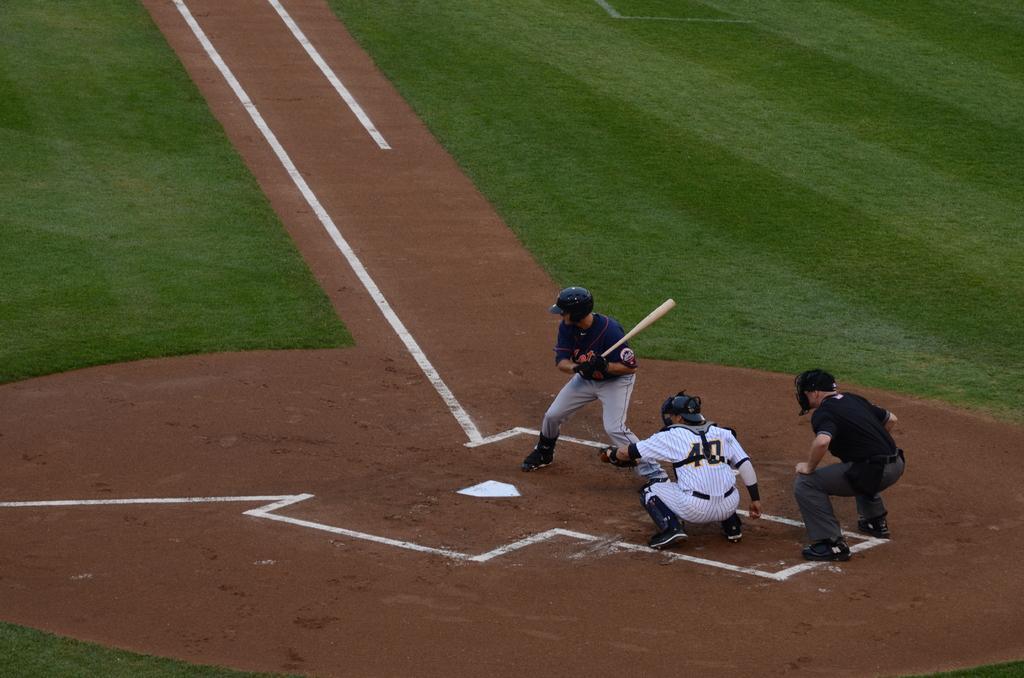How would you summarize this image in a sentence or two? There is a person who is holding a bat and is standing on the ground near two persons who are squatting on the ground on which, there are white color marks. In the background, there is grass on the ground. 